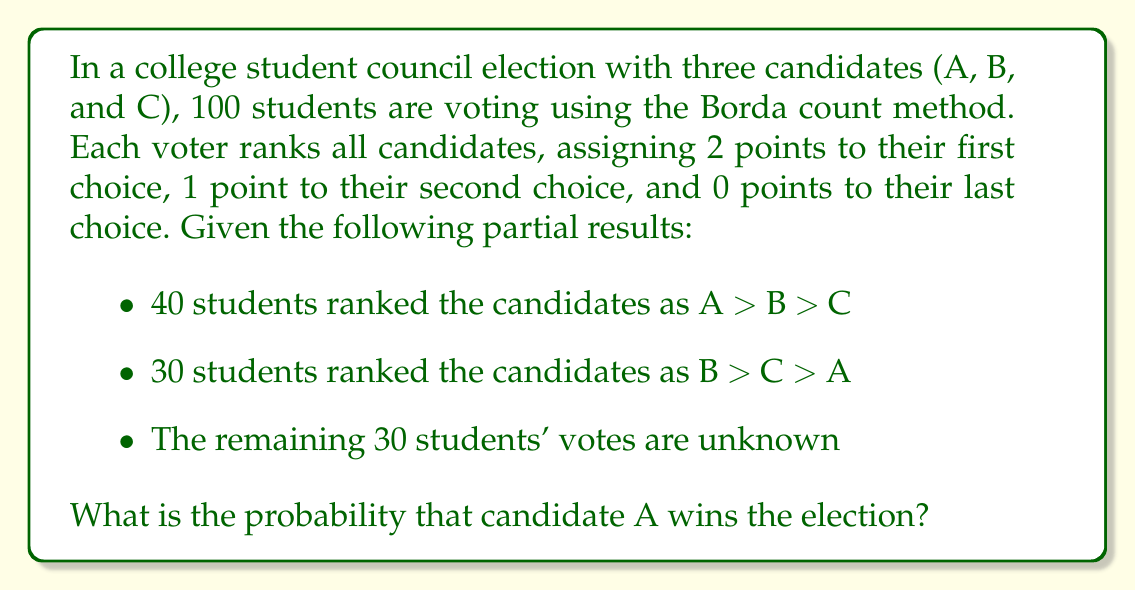Teach me how to tackle this problem. Let's approach this step-by-step:

1) First, let's calculate the known points for each candidate:

   For the 40 students who ranked A > B > C:
   A: 40 * 2 = 80 points
   B: 40 * 1 = 40 points
   C: 40 * 0 = 0 points

   For the 30 students who ranked B > C > A:
   A: 30 * 0 = 0 points
   B: 30 * 2 = 60 points
   C: 30 * 1 = 30 points

   Current totals:
   A: 80 points
   B: 100 points
   C: 30 points

2) For the remaining 30 students, there are 6 possible rankings:
   A > B > C,  A > C > B,  B > A > C,  B > C > A,  C > A > B,  C > B > A

3) For A to win, it needs to surpass B's current lead of 20 points. The best scenario for A is if all remaining 30 students rank A first, which would give A an additional 60 points.

4) The total possible additional points for each candidate from the remaining 30 votes are:
   A: 0 to 60 points
   B: 0 to 60 points
   C: 0 to 60 points

5) For A to win, it needs at least 21 of the remaining 30 students to rank it first. This is because:
   21 * 2 = 42 points for A
   9 * 1 = 9 points for A (assuming worst case where A is second for the rest)
   42 + 9 = 51 > 20 (the current lead of B)

6) The probability of exactly k students ranking A first out of the remaining 30 is:

   $P(k) = \binom{30}{k} * (\frac{1}{3})^k * (\frac{2}{3})^{30-k}$

7) The probability of A winning is the sum of probabilities for k = 21 to 30:

   $P(A wins) = \sum_{k=21}^{30} \binom{30}{k} * (\frac{1}{3})^k * (\frac{2}{3})^{30-k}$

8) Calculating this sum:

   $P(A wins) \approx 0.0138$
Answer: $0.0138$ or $1.38\%$ 